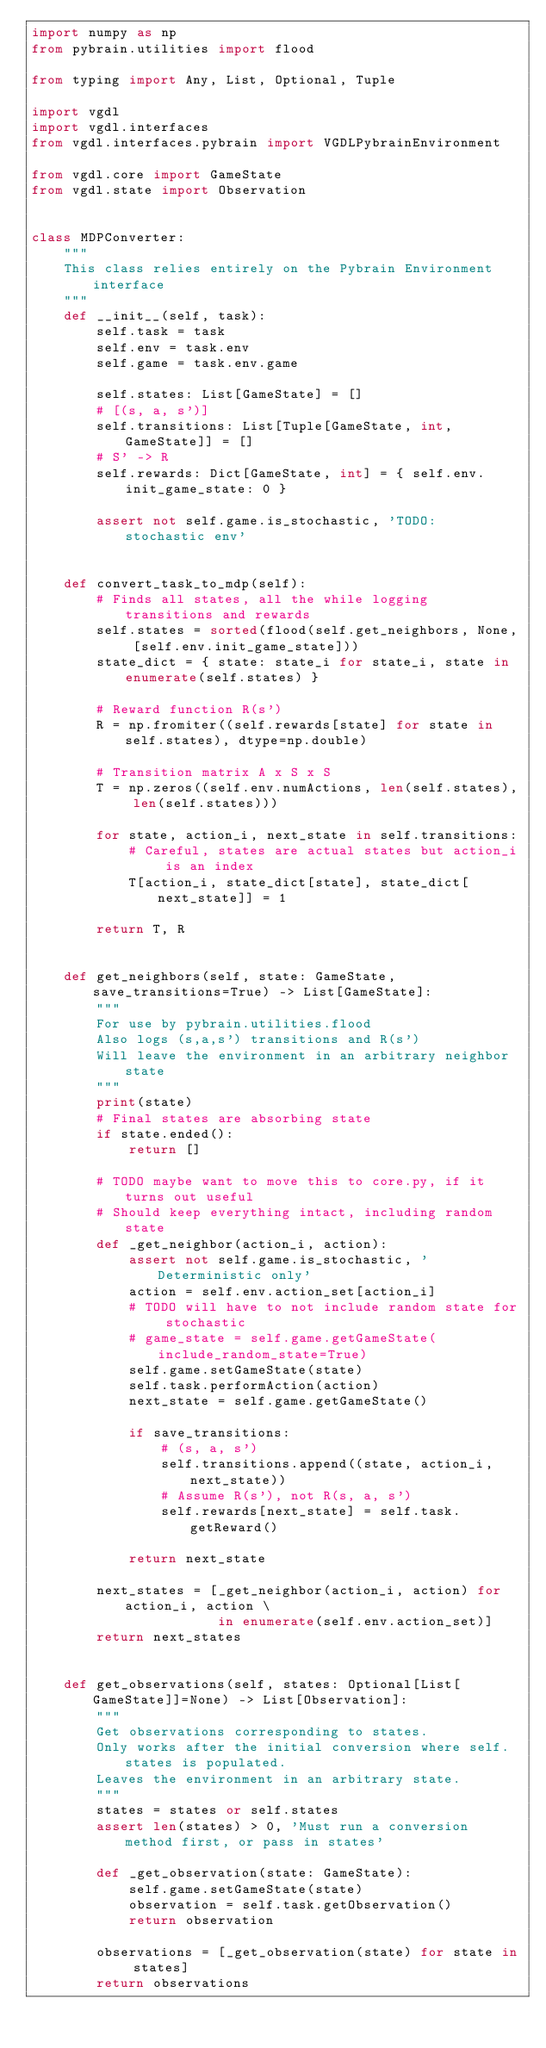Convert code to text. <code><loc_0><loc_0><loc_500><loc_500><_Python_>import numpy as np
from pybrain.utilities import flood

from typing import Any, List, Optional, Tuple

import vgdl
import vgdl.interfaces
from vgdl.interfaces.pybrain import VGDLPybrainEnvironment

from vgdl.core import GameState
from vgdl.state import Observation


class MDPConverter:
    """
    This class relies entirely on the Pybrain Environment interface
    """
    def __init__(self, task):
        self.task = task
        self.env = task.env
        self.game = task.env.game

        self.states: List[GameState] = []
        # [(s, a, s')]
        self.transitions: List[Tuple[GameState, int, GameState]] = []
        # S' -> R
        self.rewards: Dict[GameState, int] = { self.env.init_game_state: 0 }

        assert not self.game.is_stochastic, 'TODO: stochastic env'


    def convert_task_to_mdp(self):
        # Finds all states, all the while logging transitions and rewards
        self.states = sorted(flood(self.get_neighbors, None, [self.env.init_game_state]))
        state_dict = { state: state_i for state_i, state in enumerate(self.states) }

        # Reward function R(s')
        R = np.fromiter((self.rewards[state] for state in self.states), dtype=np.double)

        # Transition matrix A x S x S
        T = np.zeros((self.env.numActions, len(self.states), len(self.states)))

        for state, action_i, next_state in self.transitions:
            # Careful, states are actual states but action_i is an index
            T[action_i, state_dict[state], state_dict[next_state]] = 1

        return T, R


    def get_neighbors(self, state: GameState, save_transitions=True) -> List[GameState]:
        """
        For use by pybrain.utilities.flood
        Also logs (s,a,s') transitions and R(s')
        Will leave the environment in an arbitrary neighbor state
        """
        print(state)
        # Final states are absorbing state
        if state.ended():
            return []

        # TODO maybe want to move this to core.py, if it turns out useful
        # Should keep everything intact, including random state
        def _get_neighbor(action_i, action):
            assert not self.game.is_stochastic, 'Deterministic only'
            action = self.env.action_set[action_i]
            # TODO will have to not include random state for stochastic
            # game_state = self.game.getGameState(include_random_state=True)
            self.game.setGameState(state)
            self.task.performAction(action)
            next_state = self.game.getGameState()

            if save_transitions:
                # (s, a, s')
                self.transitions.append((state, action_i, next_state))
                # Assume R(s'), not R(s, a, s')
                self.rewards[next_state] = self.task.getReward()

            return next_state

        next_states = [_get_neighbor(action_i, action) for action_i, action \
                       in enumerate(self.env.action_set)]
        return next_states


    def get_observations(self, states: Optional[List[GameState]]=None) -> List[Observation]:
        """
        Get observations corresponding to states.
        Only works after the initial conversion where self.states is populated.
        Leaves the environment in an arbitrary state.
        """
        states = states or self.states
        assert len(states) > 0, 'Must run a conversion method first, or pass in states'

        def _get_observation(state: GameState):
            self.game.setGameState(state)
            observation = self.task.getObservation()
            return observation

        observations = [_get_observation(state) for state in states]
        return observations


</code> 